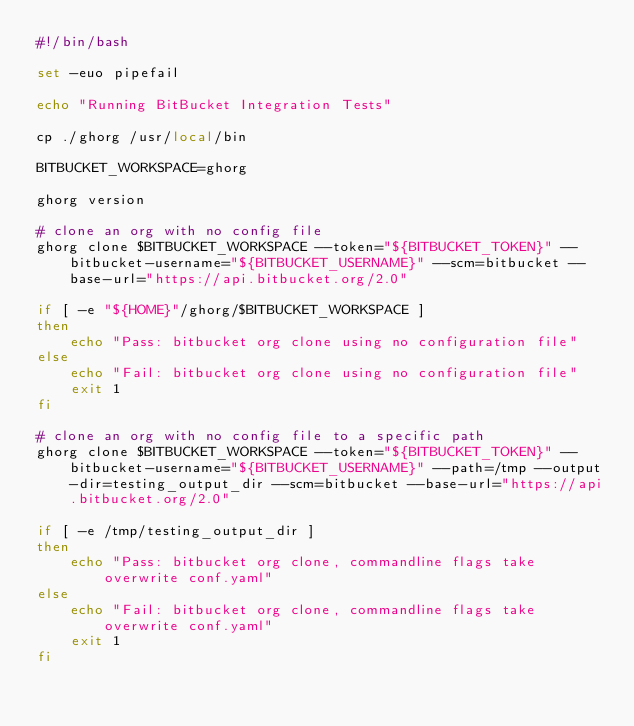Convert code to text. <code><loc_0><loc_0><loc_500><loc_500><_Bash_>#!/bin/bash

set -euo pipefail

echo "Running BitBucket Integration Tests"

cp ./ghorg /usr/local/bin

BITBUCKET_WORKSPACE=ghorg

ghorg version

# clone an org with no config file
ghorg clone $BITBUCKET_WORKSPACE --token="${BITBUCKET_TOKEN}" --bitbucket-username="${BITBUCKET_USERNAME}" --scm=bitbucket --base-url="https://api.bitbucket.org/2.0"

if [ -e "${HOME}"/ghorg/$BITBUCKET_WORKSPACE ]
then
    echo "Pass: bitbucket org clone using no configuration file"
else
    echo "Fail: bitbucket org clone using no configuration file"
    exit 1
fi

# clone an org with no config file to a specific path
ghorg clone $BITBUCKET_WORKSPACE --token="${BITBUCKET_TOKEN}" --bitbucket-username="${BITBUCKET_USERNAME}" --path=/tmp --output-dir=testing_output_dir --scm=bitbucket --base-url="https://api.bitbucket.org/2.0"

if [ -e /tmp/testing_output_dir ]
then
    echo "Pass: bitbucket org clone, commandline flags take overwrite conf.yaml"
else
    echo "Fail: bitbucket org clone, commandline flags take overwrite conf.yaml"
    exit 1
fi
</code> 